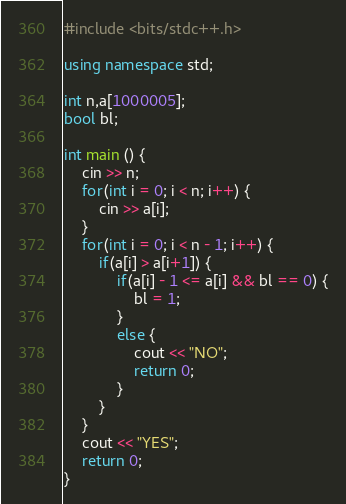Convert code to text. <code><loc_0><loc_0><loc_500><loc_500><_C++_>#include <bits/stdc++.h>

using namespace std;

int n,a[1000005];
bool bl;

int main () {
	cin >> n;
	for(int i = 0; i < n; i++) {
		cin >> a[i];
	}
	for(int i = 0; i < n - 1; i++) {
		if(a[i] > a[i+1]) {
			if(a[i] - 1 <= a[i] && bl == 0) {
				bl = 1;
			}
			else {
				cout << "NO";
				return 0;
			}
		}
	}
	cout << "YES";
	return 0;
}</code> 